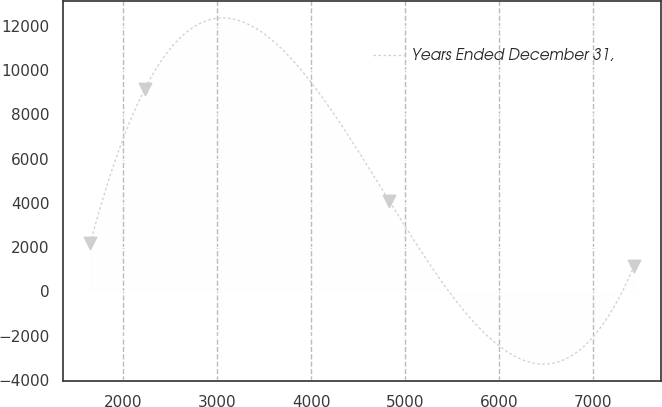Convert chart to OTSL. <chart><loc_0><loc_0><loc_500><loc_500><line_chart><ecel><fcel>Years Ended December 31,<nl><fcel>1648.15<fcel>2171.1<nl><fcel>2227.4<fcel>9128.6<nl><fcel>4835.11<fcel>4075.17<nl><fcel>7440.64<fcel>1139.72<nl></chart> 